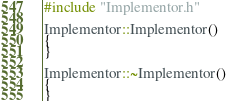Convert code to text. <code><loc_0><loc_0><loc_500><loc_500><_C++_>#include "Implementor.h"

Implementor::Implementor()
{
}

Implementor::~Implementor()
{
}

</code> 